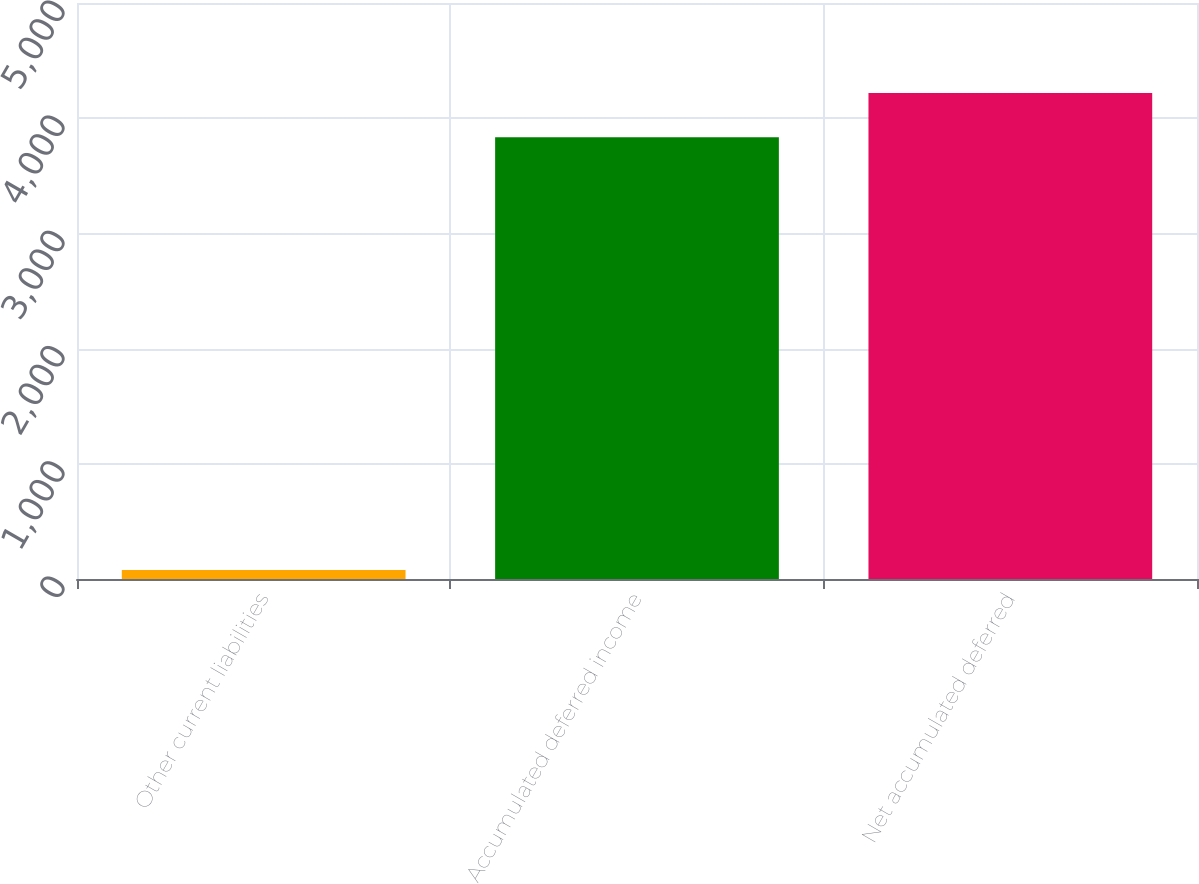<chart> <loc_0><loc_0><loc_500><loc_500><bar_chart><fcel>Other current liabilities<fcel>Accumulated deferred income<fcel>Net accumulated deferred<nl><fcel>78<fcel>3835<fcel>4218.5<nl></chart> 